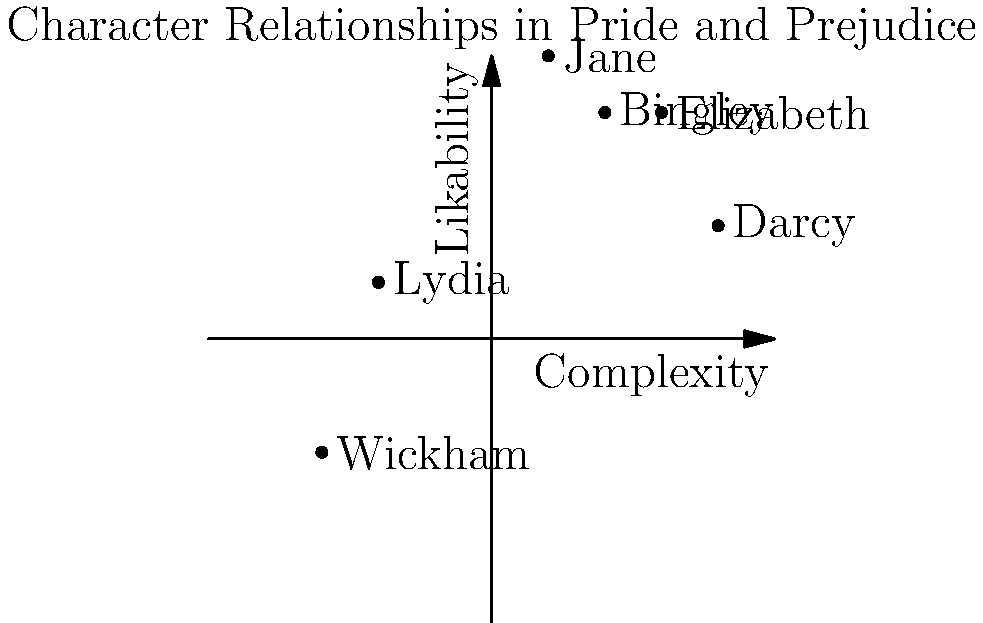In the given coordinate system representing character relationships in Jane Austen's "Pride and Prejudice," which character is plotted closest to the origin (0,0) and what might this placement suggest about their role in the novel? To answer this question, we need to follow these steps:

1. Identify the characters plotted on the graph:
   - Elizabeth (3, 4)
   - Darcy (4, 2)
   - Jane (1, 5)
   - Bingley (2, 4)
   - Wickham (-3, -2)
   - Lydia (-2, 1)

2. Calculate the distance of each character from the origin (0,0) using the distance formula:
   $d = \sqrt{x^2 + y^2}$

3. Calculate distances:
   - Elizabeth: $\sqrt{3^2 + 4^2} = 5$
   - Darcy: $\sqrt{4^2 + 2^2} = \sqrt{20} \approx 4.47$
   - Jane: $\sqrt{1^2 + 5^2} = \sqrt{26} \approx 5.10$
   - Bingley: $\sqrt{2^2 + 4^2} = \sqrt{20} \approx 4.47$
   - Wickham: $\sqrt{(-3)^2 + (-2)^2} = \sqrt{13} \approx 3.61$
   - Lydia: $\sqrt{(-2)^2 + 1^2} = \sqrt{5} \approx 2.24$

4. Identify the character closest to the origin:
   Lydia is closest to (0,0) with a distance of approximately 2.24.

5. Interpret the placement:
   Being closest to the origin suggests that Lydia has a relatively neutral position in terms of complexity and likability. This could imply that she plays a more peripheral or less developed role in the novel compared to other characters, or that her character is less extreme in terms of complexity and likability.
Answer: Lydia; suggests a more peripheral or less developed role in the novel. 